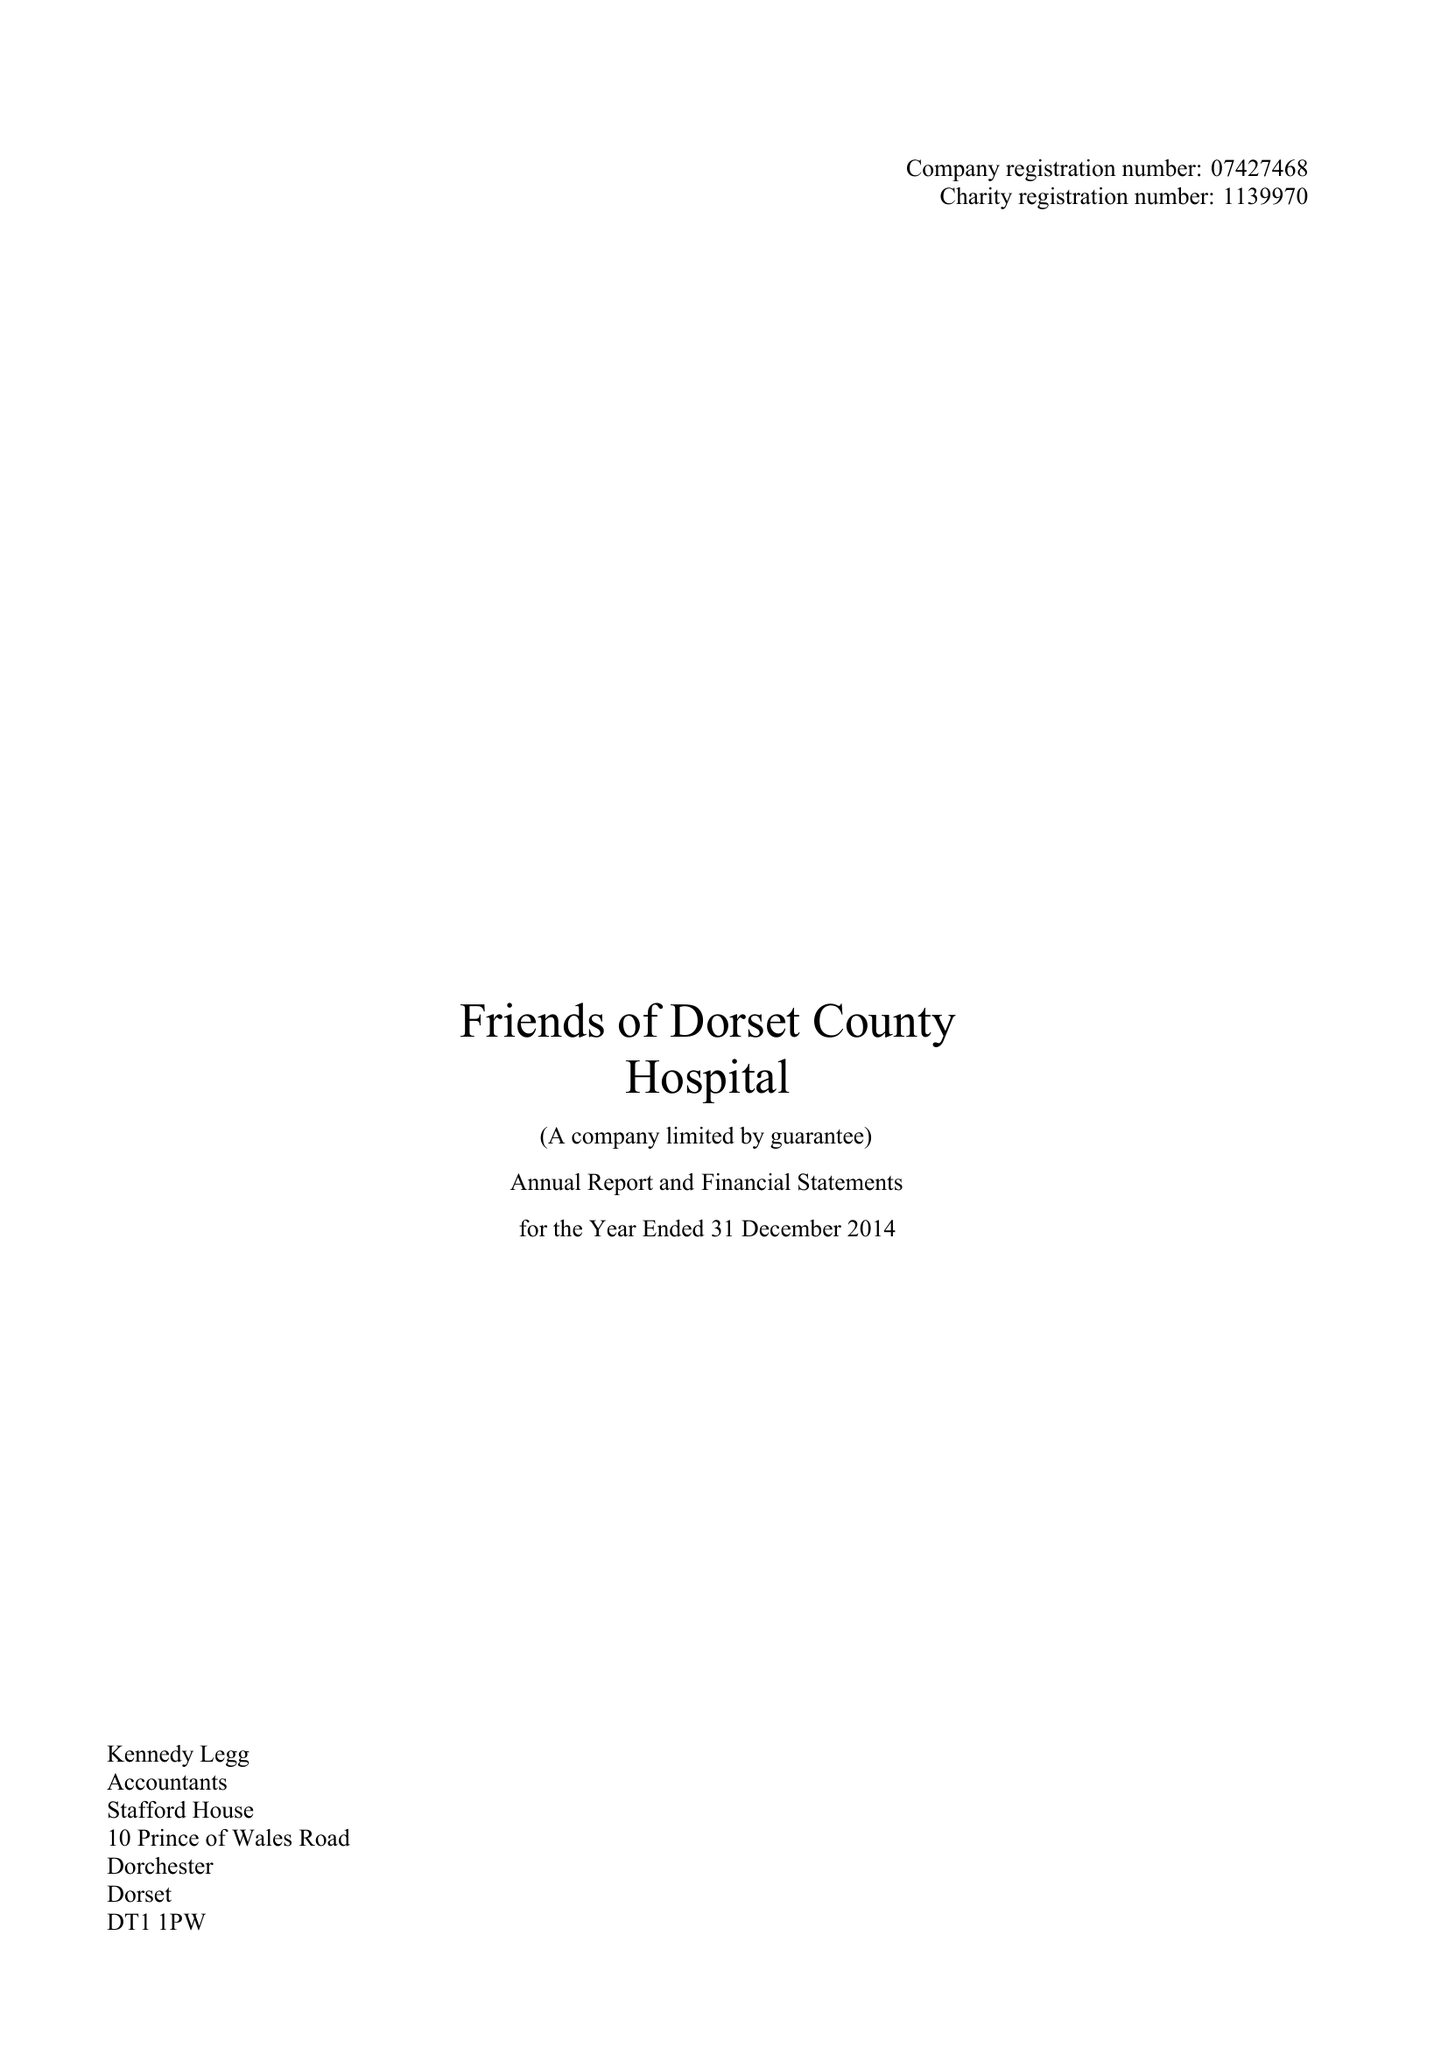What is the value for the address__postcode?
Answer the question using a single word or phrase. DT1 1PW 